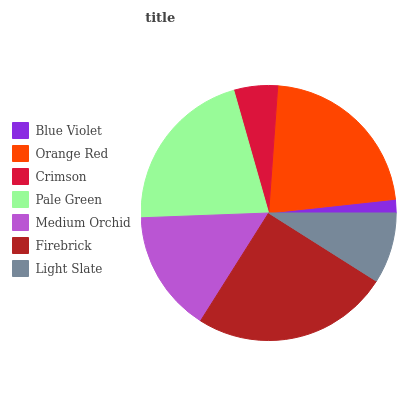Is Blue Violet the minimum?
Answer yes or no. Yes. Is Firebrick the maximum?
Answer yes or no. Yes. Is Orange Red the minimum?
Answer yes or no. No. Is Orange Red the maximum?
Answer yes or no. No. Is Orange Red greater than Blue Violet?
Answer yes or no. Yes. Is Blue Violet less than Orange Red?
Answer yes or no. Yes. Is Blue Violet greater than Orange Red?
Answer yes or no. No. Is Orange Red less than Blue Violet?
Answer yes or no. No. Is Medium Orchid the high median?
Answer yes or no. Yes. Is Medium Orchid the low median?
Answer yes or no. Yes. Is Crimson the high median?
Answer yes or no. No. Is Pale Green the low median?
Answer yes or no. No. 